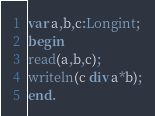Convert code to text. <code><loc_0><loc_0><loc_500><loc_500><_Pascal_>var a,b,c:Longint;
begin
read(a,b,c);
writeln(c div a*b);
end.</code> 